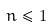Convert formula to latex. <formula><loc_0><loc_0><loc_500><loc_500>n \leq 1</formula> 